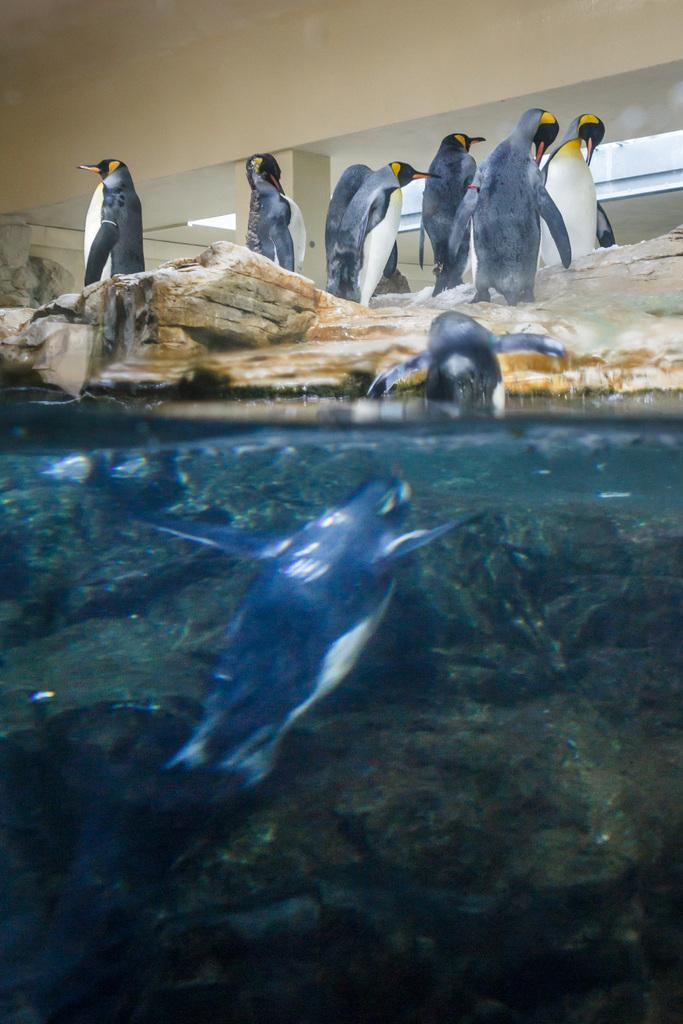What type of animals are in the image? There are penguins in the image. What else can be seen in the image besides the penguins? There are rocks and a wall visible in the image. What is the background of the image like? There are other objects in the background of the image, and there is water visible at the bottom. Where are the penguins located in the image? Penguins are present at the bottom of the image. Who is the creator of the penguins in the image? The image is a photograph or illustration, not a creation by a specific individual. The penguins are real animals, and their existence is not dependent on a creator in the context of the image. 